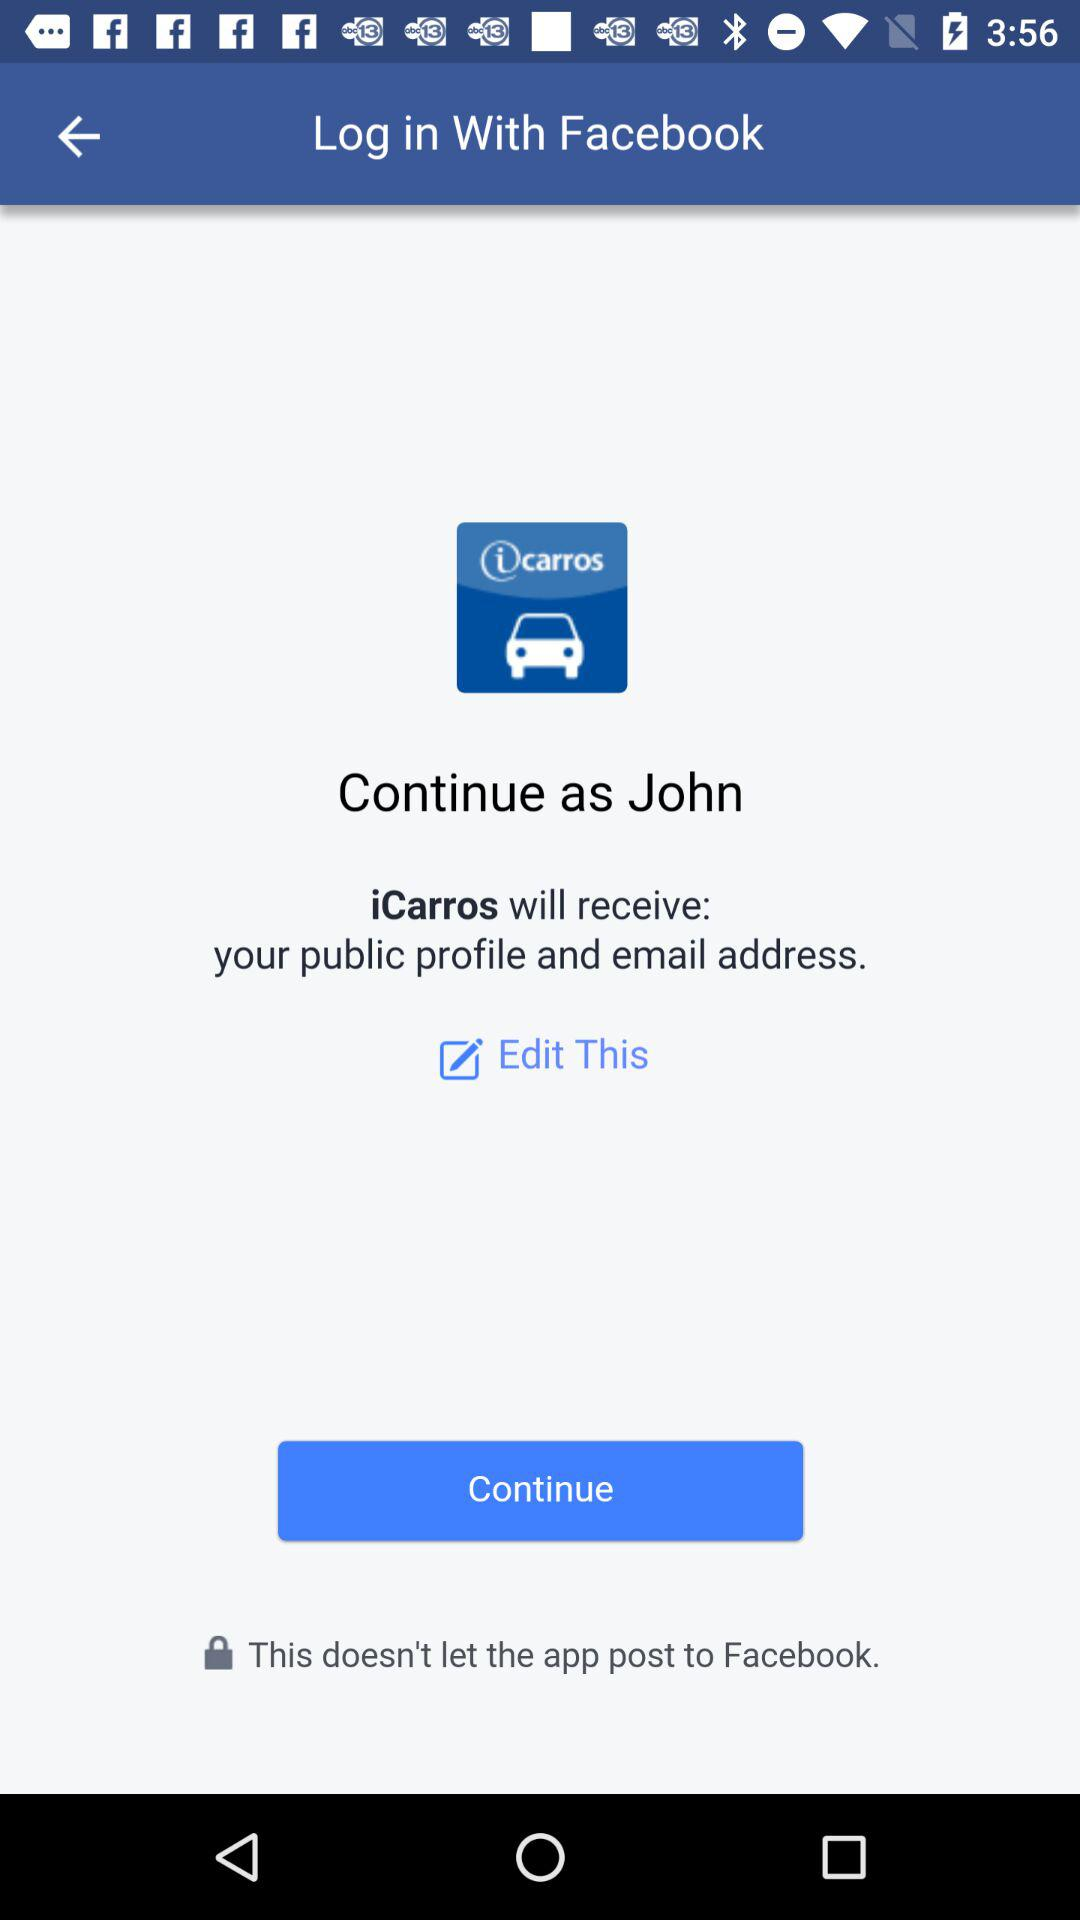What account am I using to log in? You are using your "Facebook" account to log in. 